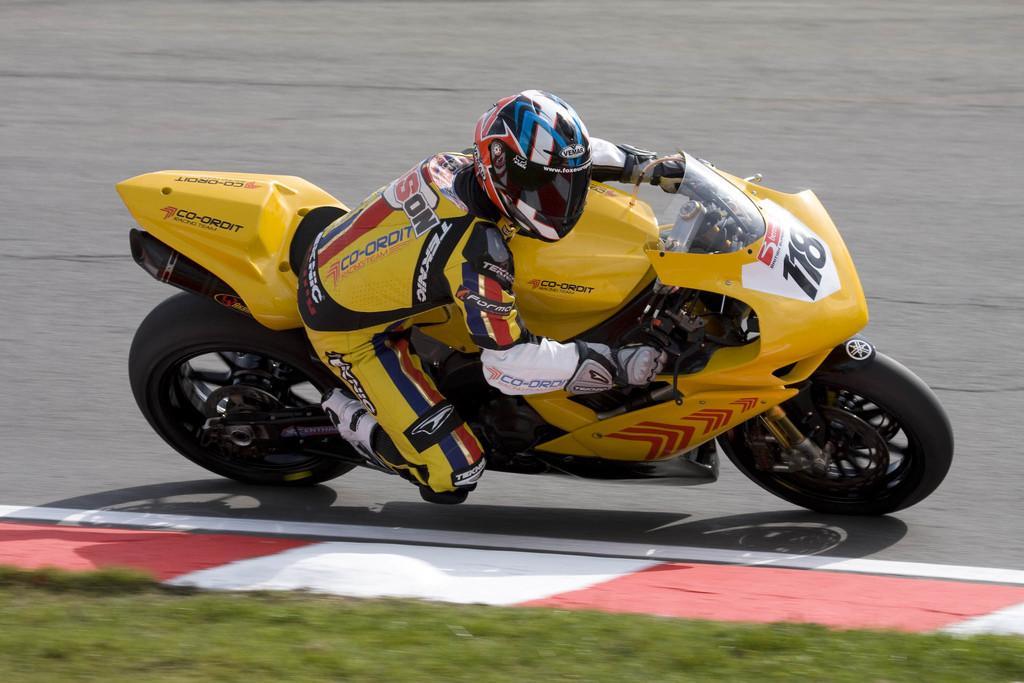How would you summarize this image in a sentence or two? In this image there is a biker riding a bike on the track, beside the track there is grass. 